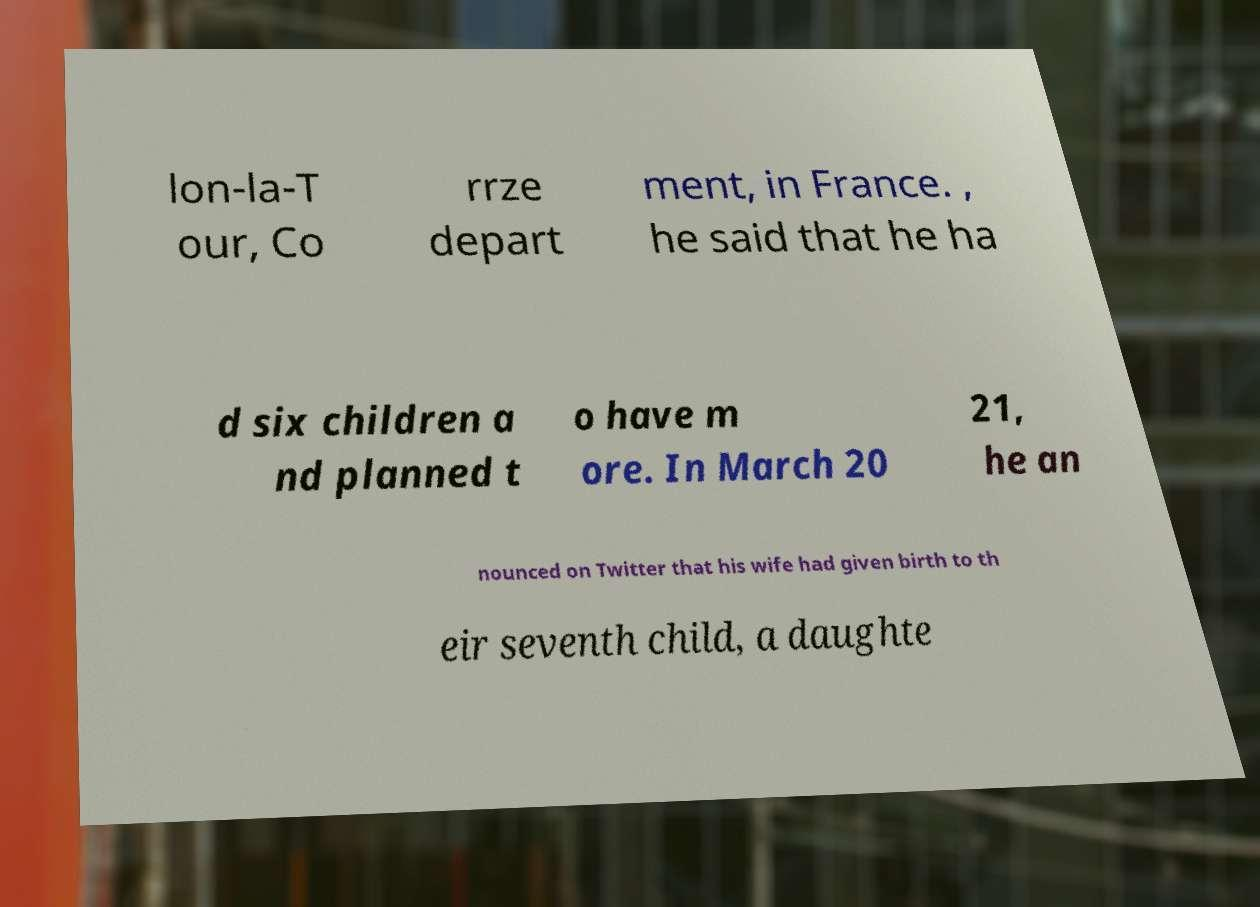Could you assist in decoding the text presented in this image and type it out clearly? lon-la-T our, Co rrze depart ment, in France. , he said that he ha d six children a nd planned t o have m ore. In March 20 21, he an nounced on Twitter that his wife had given birth to th eir seventh child, a daughte 